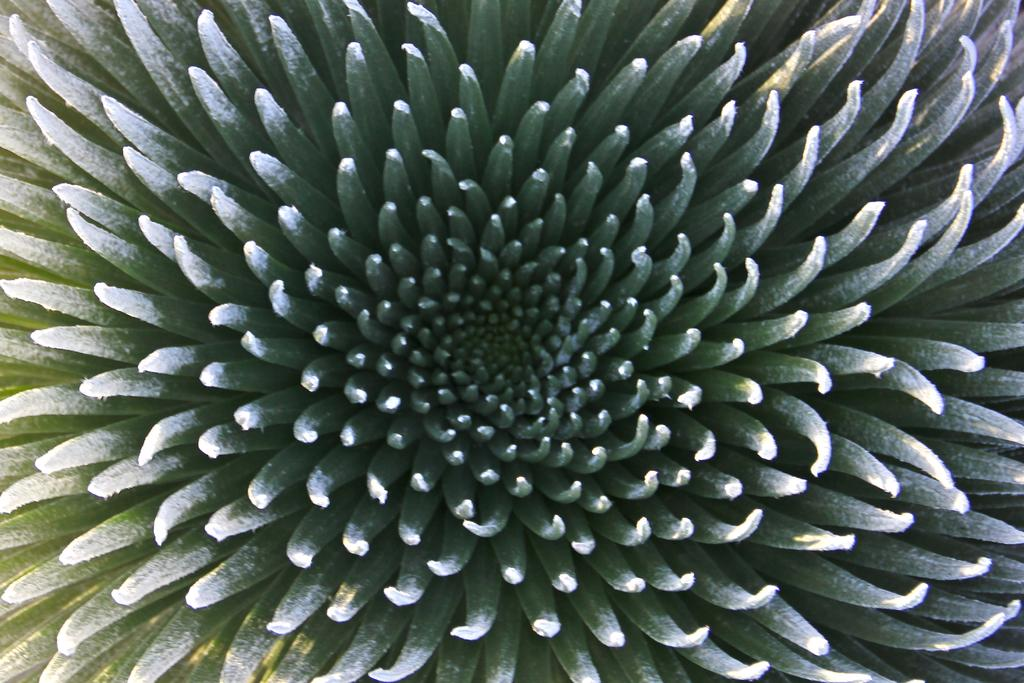What is the main subject of the image? The main subject of the image is a flower. Can you describe the flower in the image? The image is a zoomed in picture of a flower, so we can see the details of the petals, stamen, and other parts of the flower. What type of knot is used to hold the flower in the image? There is no knot present in the image, as it is a picture of a flower and not a tied object. 